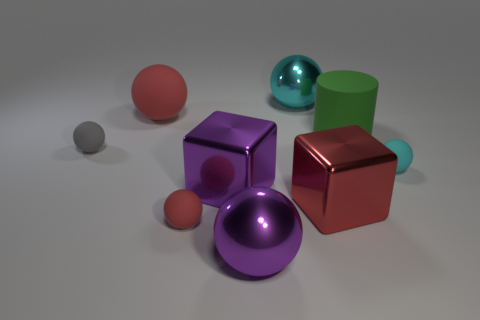How many red balls must be subtracted to get 1 red balls? 1 Add 1 purple metal spheres. How many objects exist? 10 Subtract all small cyan spheres. How many spheres are left? 5 Subtract 1 cubes. How many cubes are left? 1 Subtract all brown cylinders. Subtract all red spheres. How many cylinders are left? 1 Subtract all red cubes. How many gray cylinders are left? 0 Subtract all red rubber objects. Subtract all tiny gray balls. How many objects are left? 6 Add 6 large purple things. How many large purple things are left? 8 Add 1 large green cylinders. How many large green cylinders exist? 2 Subtract all red blocks. How many blocks are left? 1 